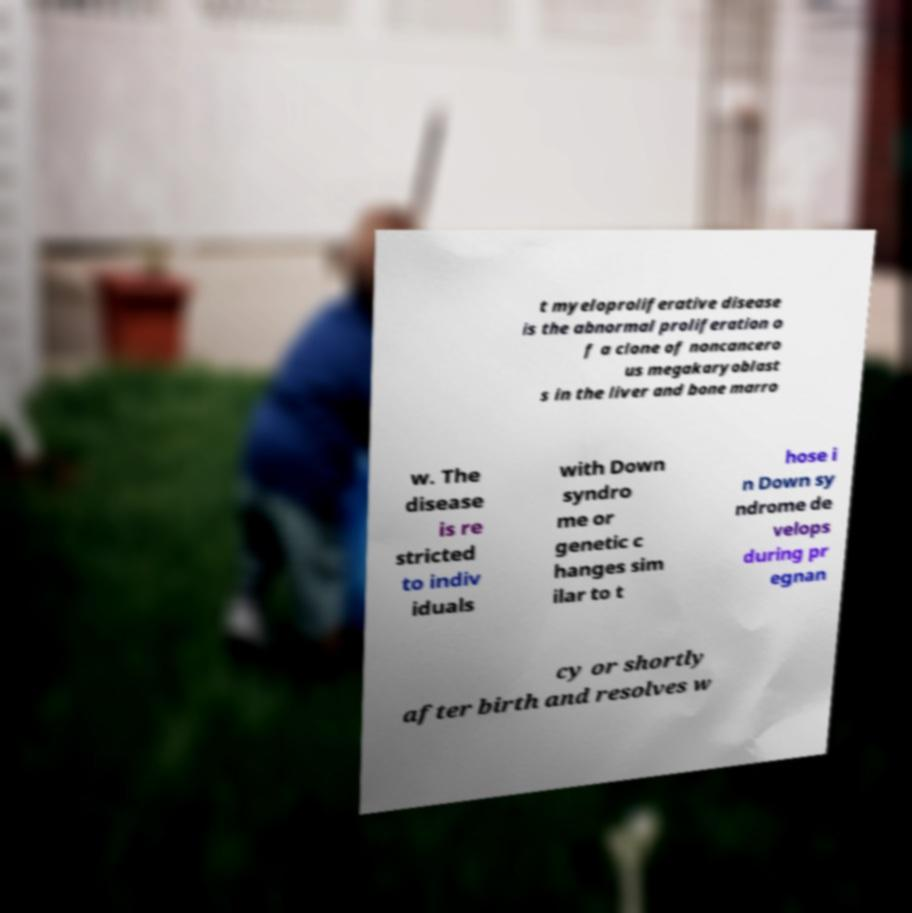Please identify and transcribe the text found in this image. t myeloproliferative disease is the abnormal proliferation o f a clone of noncancero us megakaryoblast s in the liver and bone marro w. The disease is re stricted to indiv iduals with Down syndro me or genetic c hanges sim ilar to t hose i n Down sy ndrome de velops during pr egnan cy or shortly after birth and resolves w 